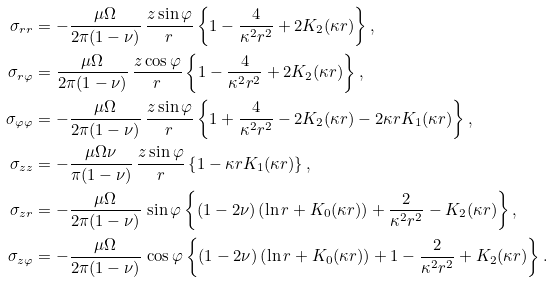Convert formula to latex. <formula><loc_0><loc_0><loc_500><loc_500>\sigma _ { r r } & = - \frac { \mu \Omega } { 2 \pi ( 1 - \nu ) } \, \frac { z \sin \varphi } { r } \left \{ 1 - \frac { 4 } { \kappa ^ { 2 } r ^ { 2 } } + 2 K _ { 2 } ( \kappa r ) \right \} , \\ \sigma _ { r \varphi } & = \frac { \mu \Omega } { 2 \pi ( 1 - \nu ) } \, \frac { z \cos \varphi } { r } \left \{ 1 - \frac { 4 } { \kappa ^ { 2 } r ^ { 2 } } + 2 K _ { 2 } ( \kappa r ) \right \} , \\ \sigma _ { \varphi \varphi } & = - \frac { \mu \Omega } { 2 \pi ( 1 - \nu ) } \, \frac { z \sin \varphi } { r } \left \{ 1 + \frac { 4 } { \kappa ^ { 2 } r ^ { 2 } } - 2 K _ { 2 } ( \kappa r ) - 2 \kappa r K _ { 1 } ( \kappa r ) \right \} , \\ \sigma _ { z z } & = - \frac { \mu \Omega \nu } { \pi ( 1 - \nu ) } \, \frac { z \sin \varphi } { r } \left \{ 1 - \kappa r K _ { 1 } ( \kappa r ) \right \} , \\ \sigma _ { z r } & = - \frac { \mu \Omega } { 2 \pi ( 1 - \nu ) } \, \sin \varphi \left \{ ( 1 - 2 \nu ) \left ( \ln r + K _ { 0 } ( \kappa r ) \right ) + \frac { 2 } { \kappa ^ { 2 } r ^ { 2 } } - K _ { 2 } ( \kappa r ) \right \} , \\ \sigma _ { z \varphi } & = - \frac { \mu \Omega } { 2 \pi ( 1 - \nu ) } \, \cos \varphi \left \{ ( 1 - 2 \nu ) \left ( \ln r + K _ { 0 } ( \kappa r ) \right ) + 1 - \frac { 2 } { \kappa ^ { 2 } r ^ { 2 } } + K _ { 2 } ( \kappa r ) \right \} .</formula> 